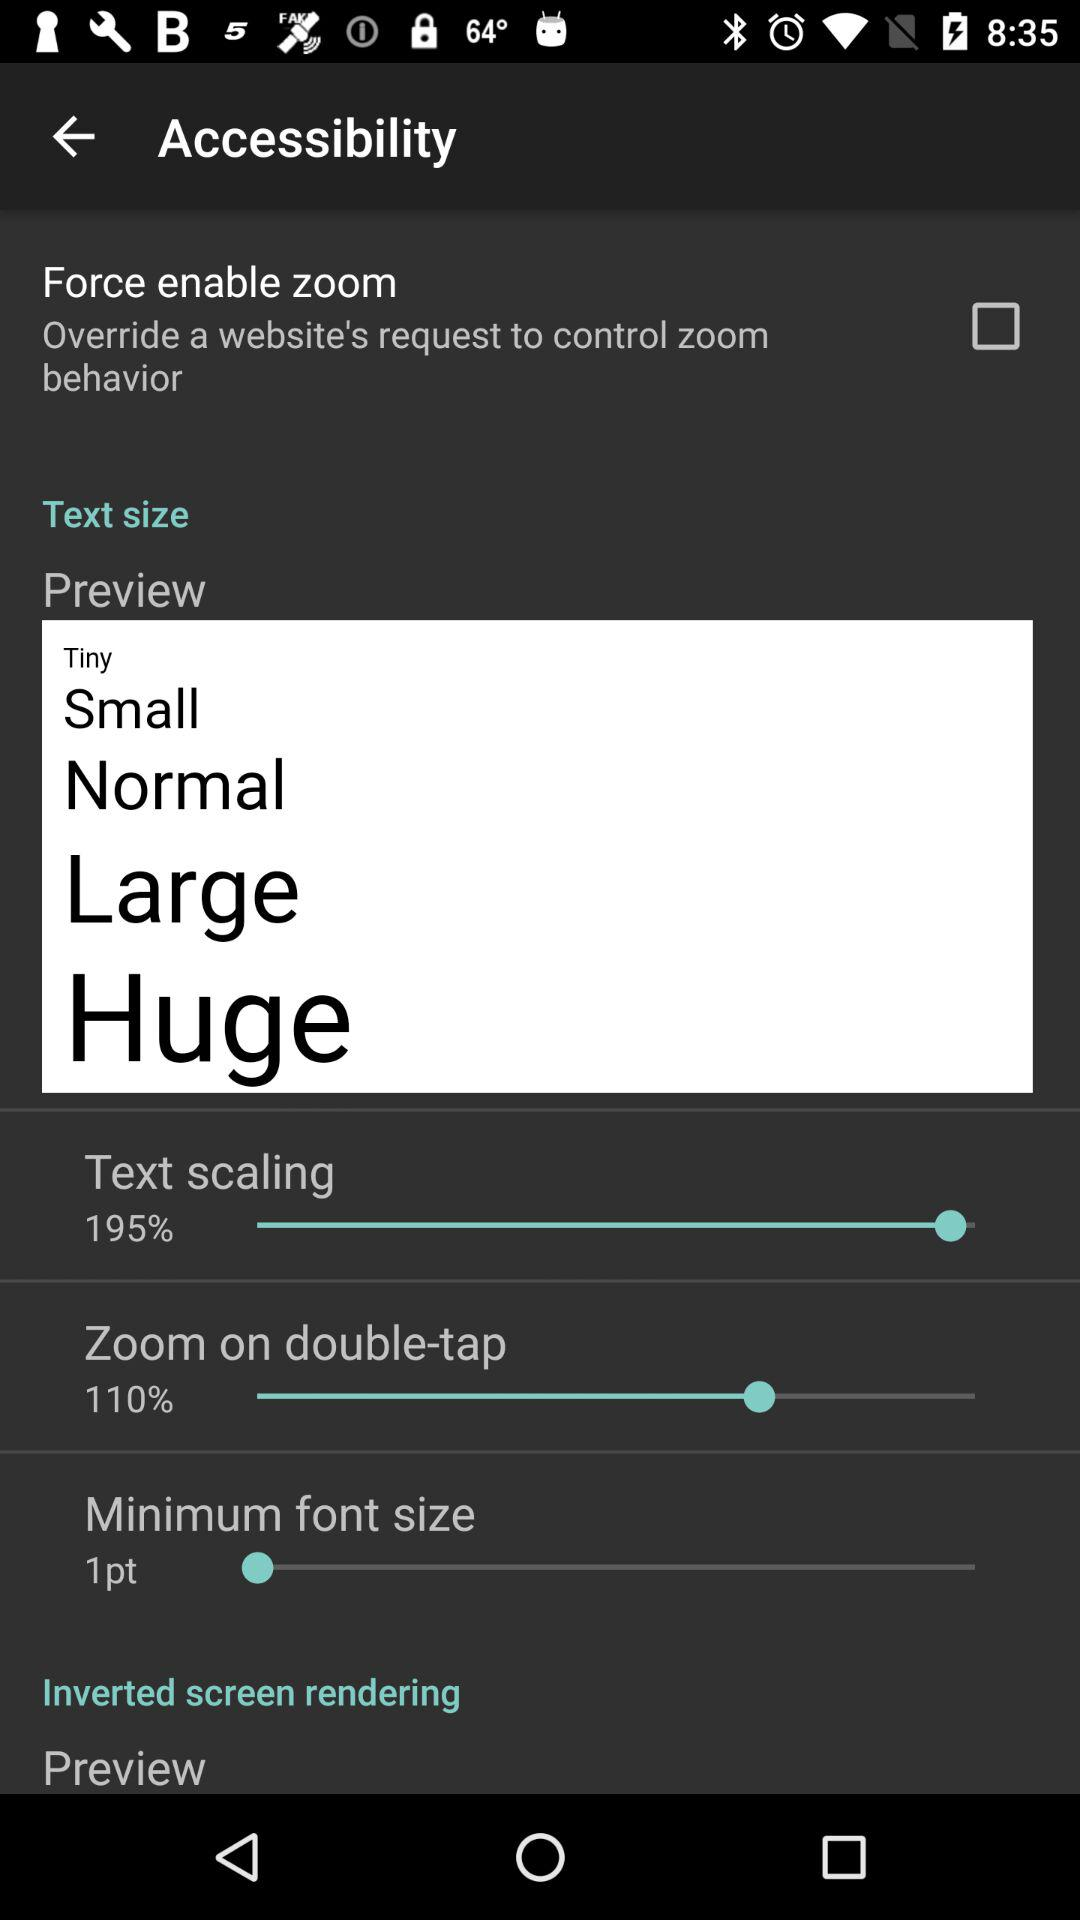What is the percentage of "Text scaling"? The percentage is 195. 